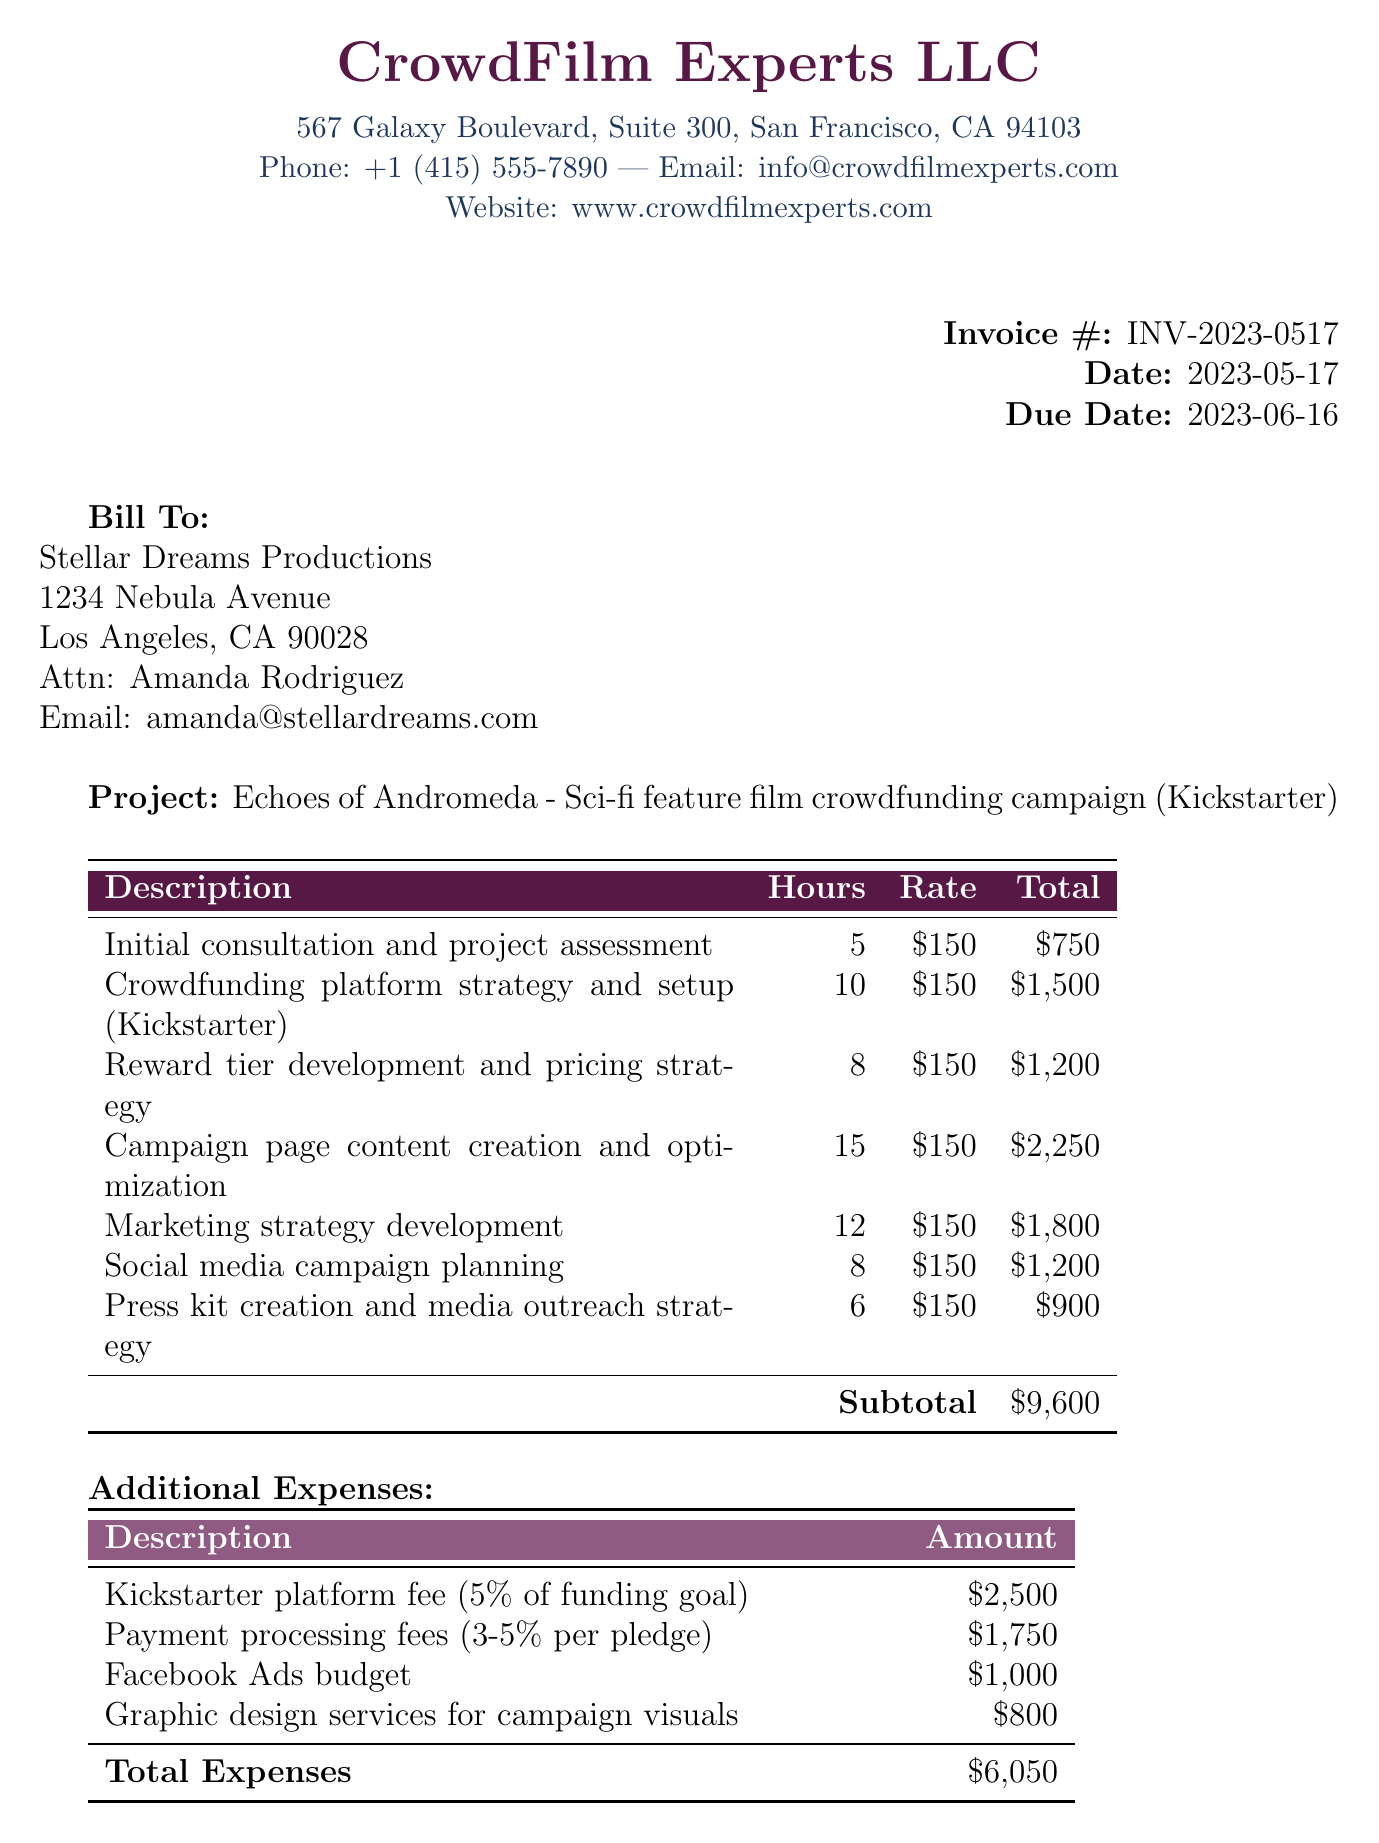What is the invoice number? The invoice number is specified in the invoice details section of the document.
Answer: INV-2023-0517 Who is the contact person for the client? The contact person's name for the client is mentioned under client info.
Answer: Amanda Rodriguez What is the total due amount? The total due amount is calculated as the sum of services and expenses.
Answer: 15650 USD How many hours were spent on social media campaign planning? The hours spent for social media campaign planning is listed in the services section.
Answer: 8 What is the platform used for the crowdfunding campaign? The crowdfunding platform being used is specified in the project details section of the document.
Answer: Kickstarter What is the payment method mentioned? The payment method is stated under the payment terms section.
Answer: Bank transfer or PayPal What percentage is charged for the Kickstarter platform fee? The percentage charged for the Kickstarter platform fee is given in the expenses section of the document.
Answer: 5% How many total hours were spent on consulting services? The total hours can be summed up from the services listed in the document.
Answer: 64 What is the late fee for unpaid balance? The late fee amount is noted in the payment terms section.
Answer: 1.5% per month 